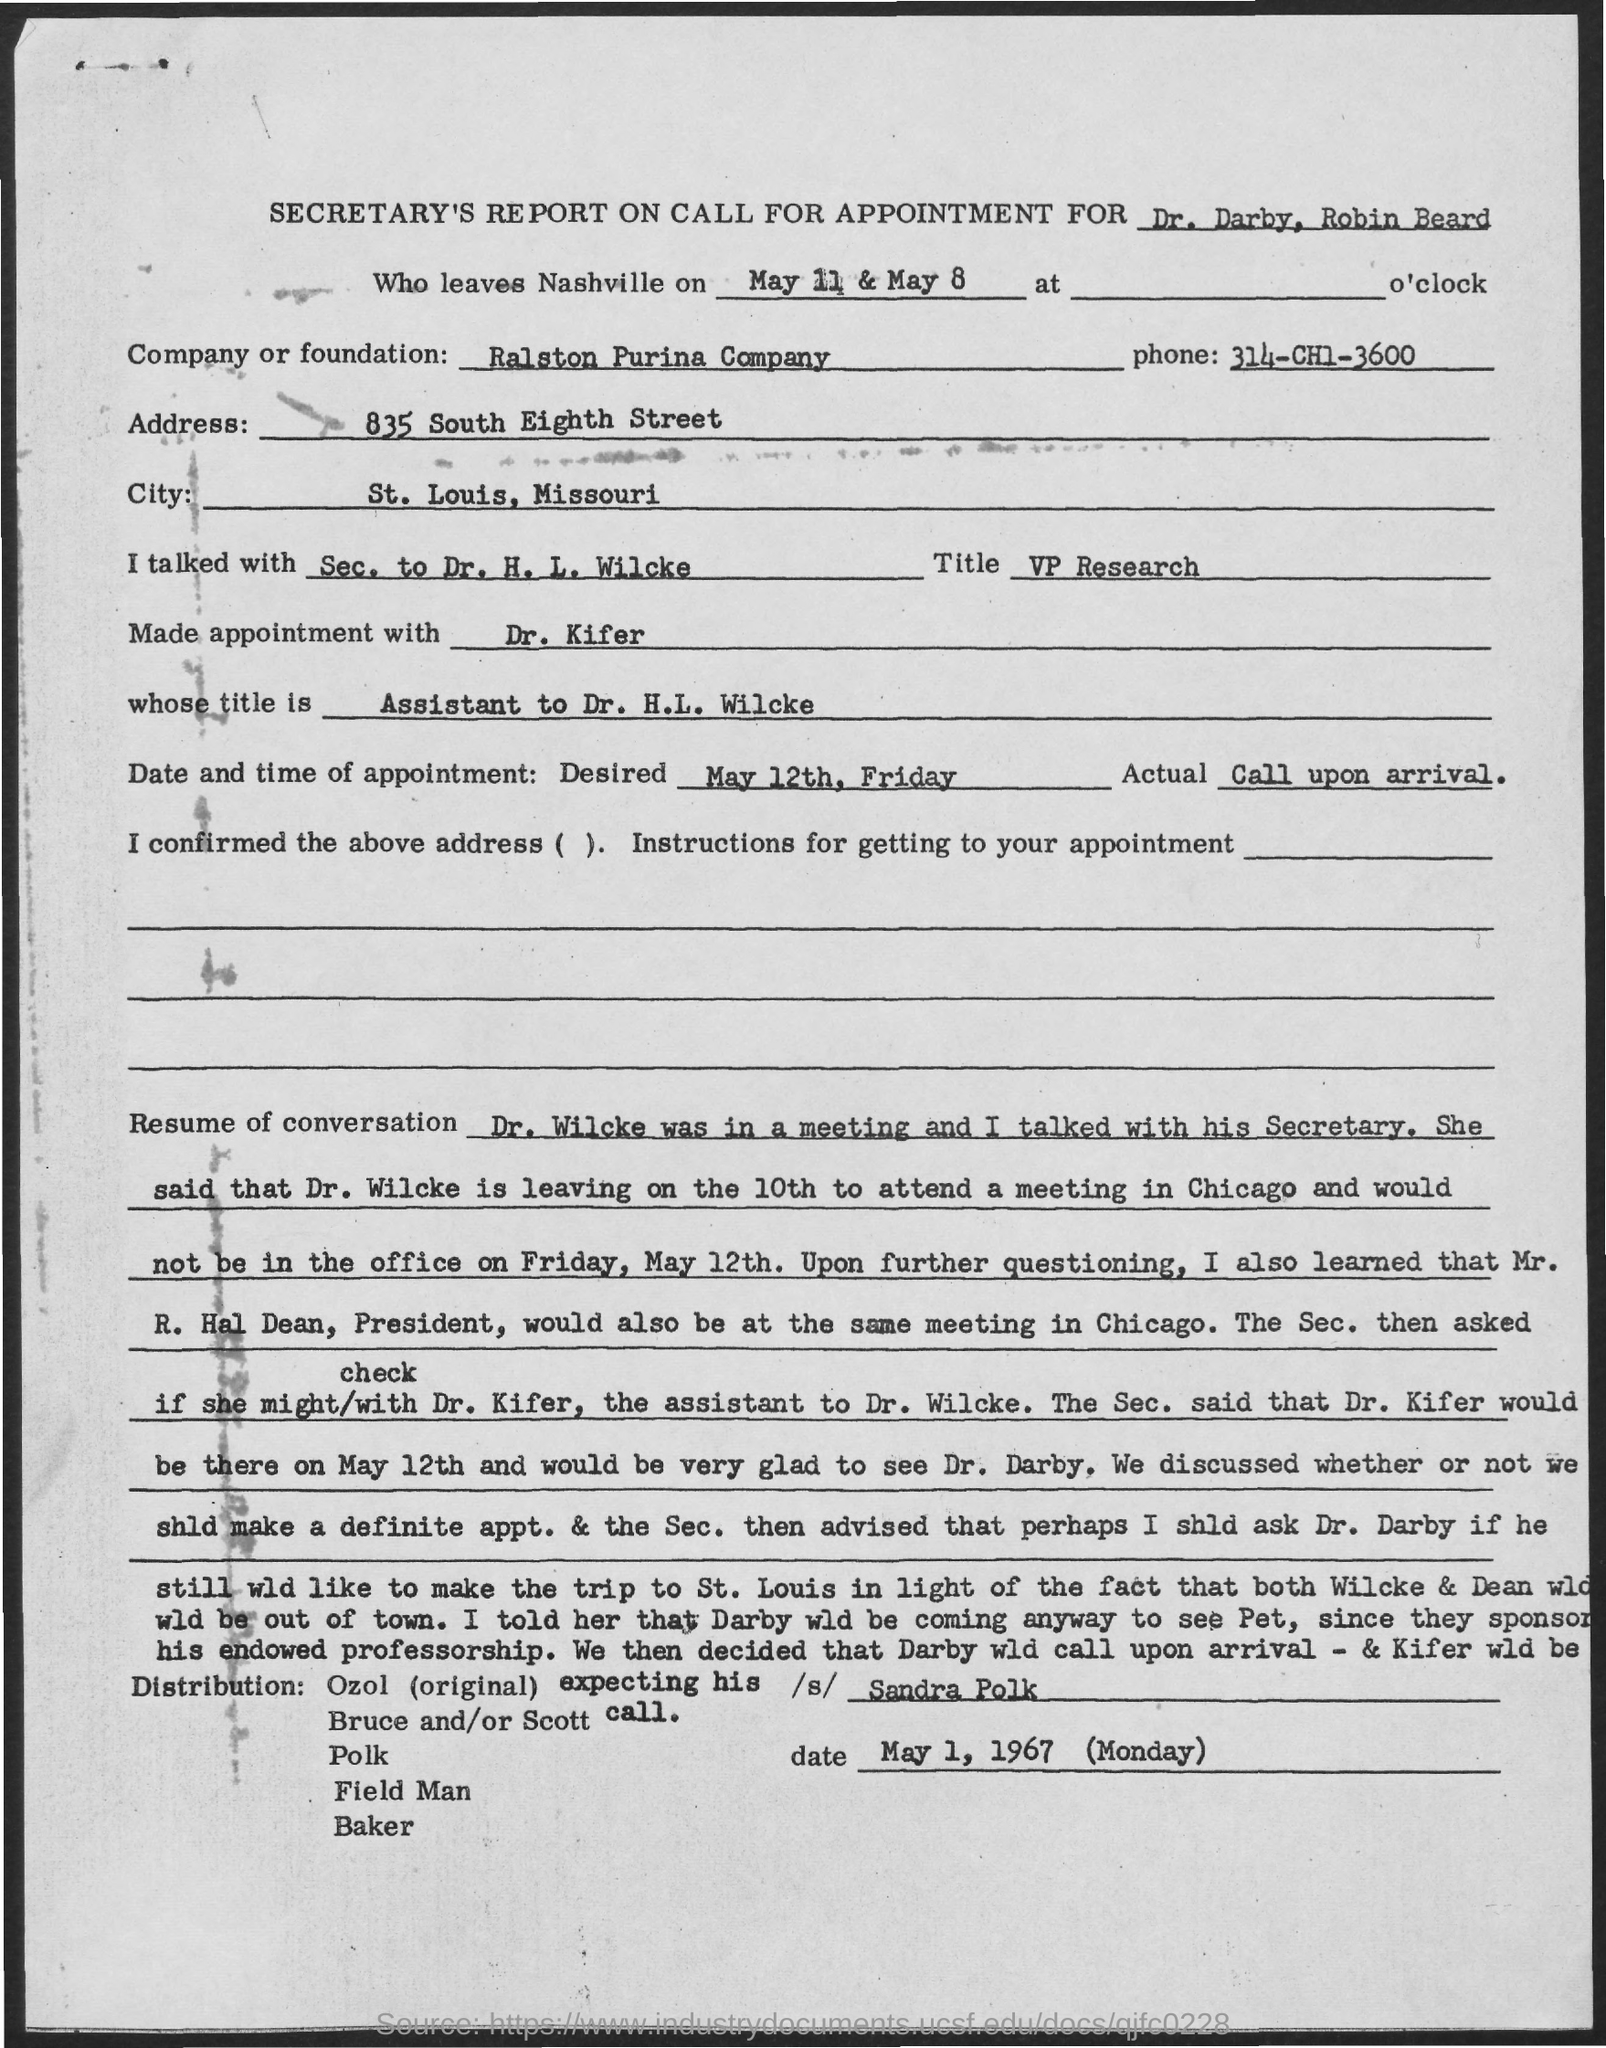What is the company or foundation name?
Offer a very short reply. Ralston Purina Company. What is the phone number ?
Your answer should be very brief. 314-CH1-3600. What is the address of ralston purina company?
Your answer should be very brief. 835 South Eighth Street. What is the desired date of appointment ?
Offer a terse response. May 12th, Friday. When are dr. darby, robin beard leaving nashville ?
Offer a terse response. May 11 & May 8. What the title of dr. h.l. wilcke ?
Keep it short and to the point. VP Research. 